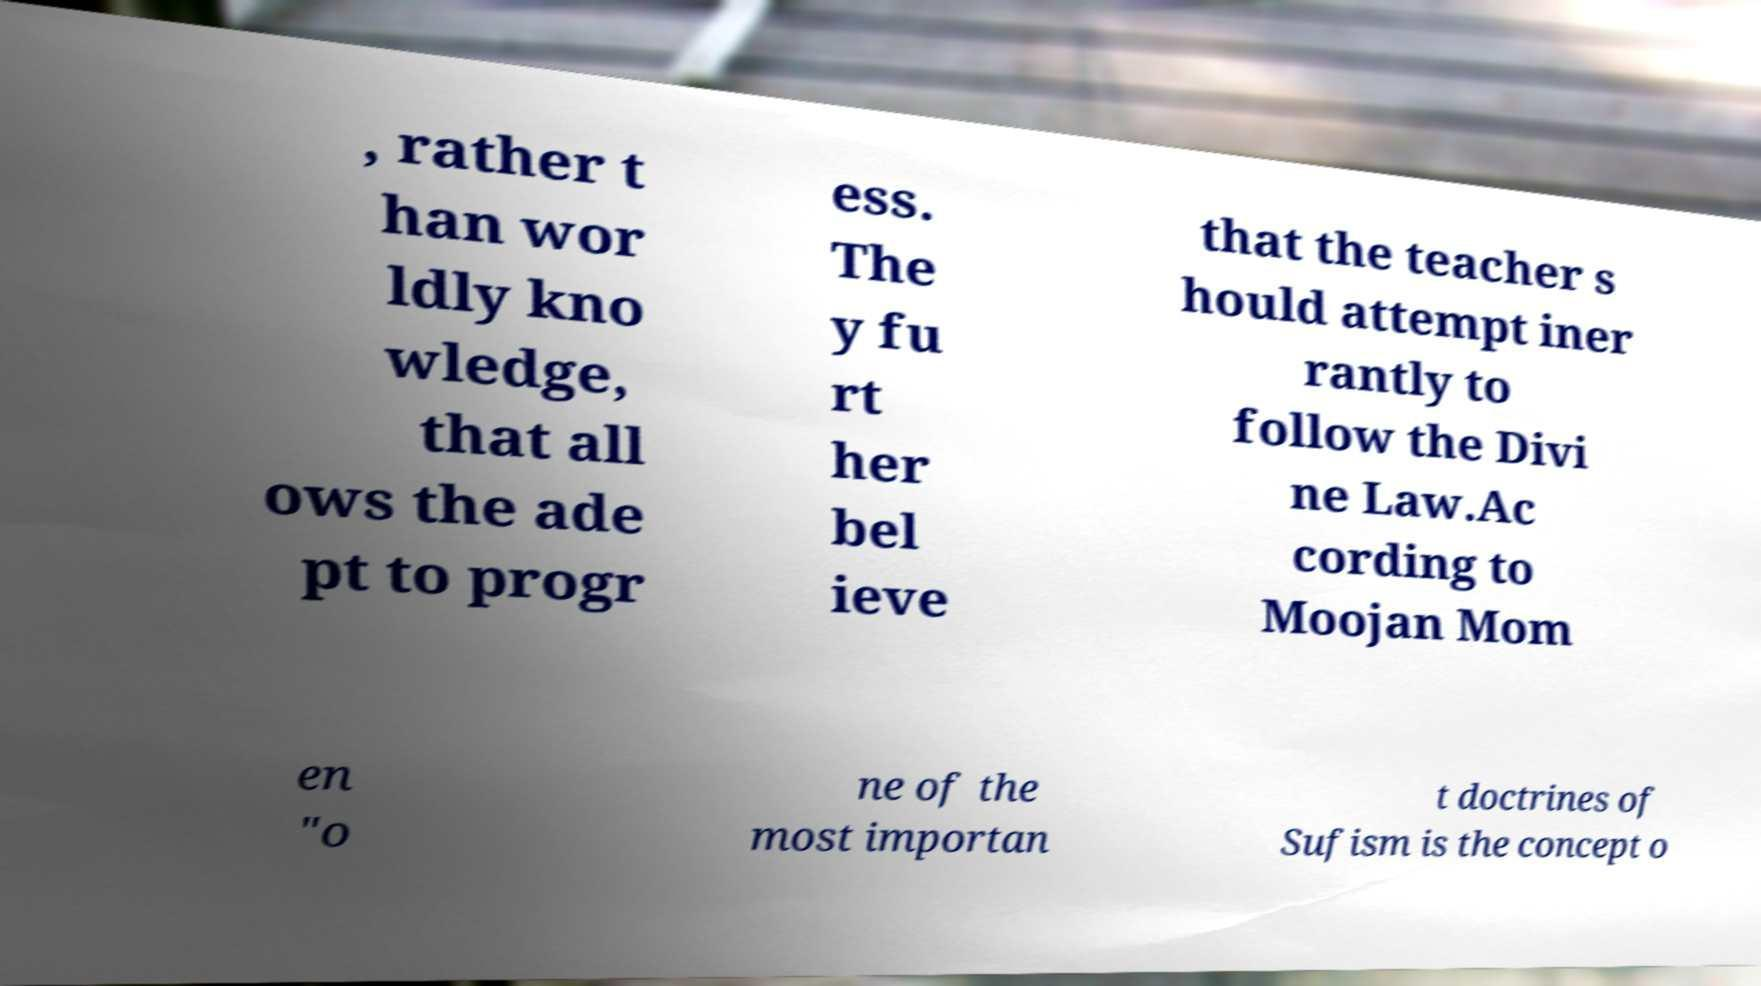Please identify and transcribe the text found in this image. , rather t han wor ldly kno wledge, that all ows the ade pt to progr ess. The y fu rt her bel ieve that the teacher s hould attempt iner rantly to follow the Divi ne Law.Ac cording to Moojan Mom en "o ne of the most importan t doctrines of Sufism is the concept o 